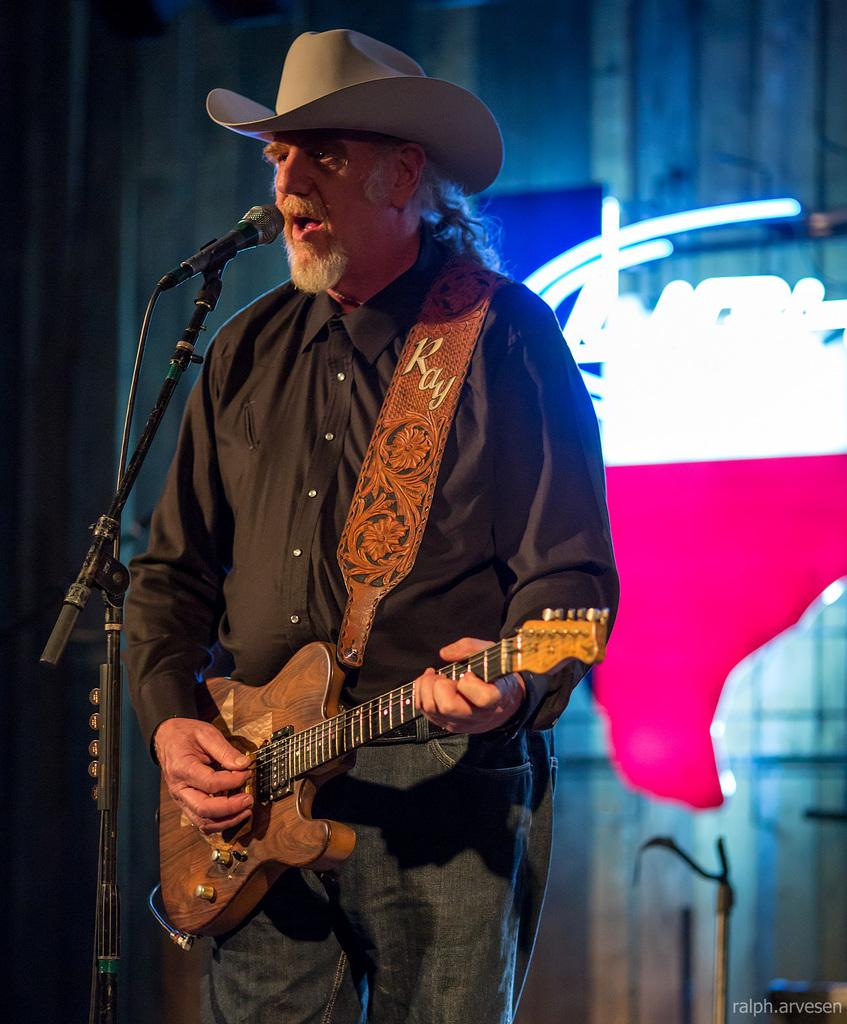What is the man in the image doing? The man is standing in front of a mic and holding a guitar. What is the man wearing on his head? The man is wearing a hat. What can be seen in the background of the image? There is light visible in the background of the image. What type of pollution is visible in the image? There is no pollution visible in the image. What is the man eating for dinner in the image? There is no dinner or food present in the image. 